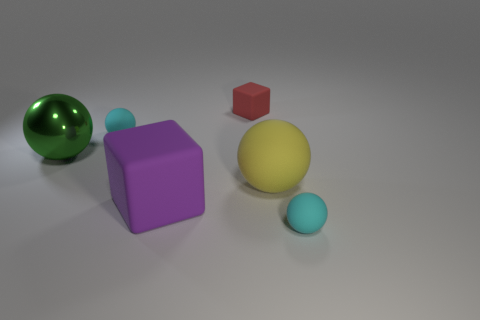Is the number of red cylinders greater than the number of red rubber blocks?
Your answer should be compact. No. Is there any other thing that is the same color as the metallic object?
Your response must be concise. No. What is the shape of the large purple object that is the same material as the large yellow ball?
Give a very brief answer. Cube. What material is the small sphere right of the cube that is behind the shiny thing?
Make the answer very short. Rubber. Do the big rubber thing that is behind the purple rubber thing and the metallic object have the same shape?
Your answer should be compact. Yes. Is the number of big yellow matte spheres that are behind the big matte sphere greater than the number of blue shiny spheres?
Keep it short and to the point. No. Is there anything else that has the same material as the purple block?
Keep it short and to the point. Yes. What number of cylinders are either yellow matte objects or purple objects?
Your answer should be compact. 0. The small matte ball behind the small cyan object in front of the purple object is what color?
Give a very brief answer. Cyan. Is the color of the big shiny ball the same as the big rubber thing that is on the right side of the purple rubber object?
Keep it short and to the point. No. 